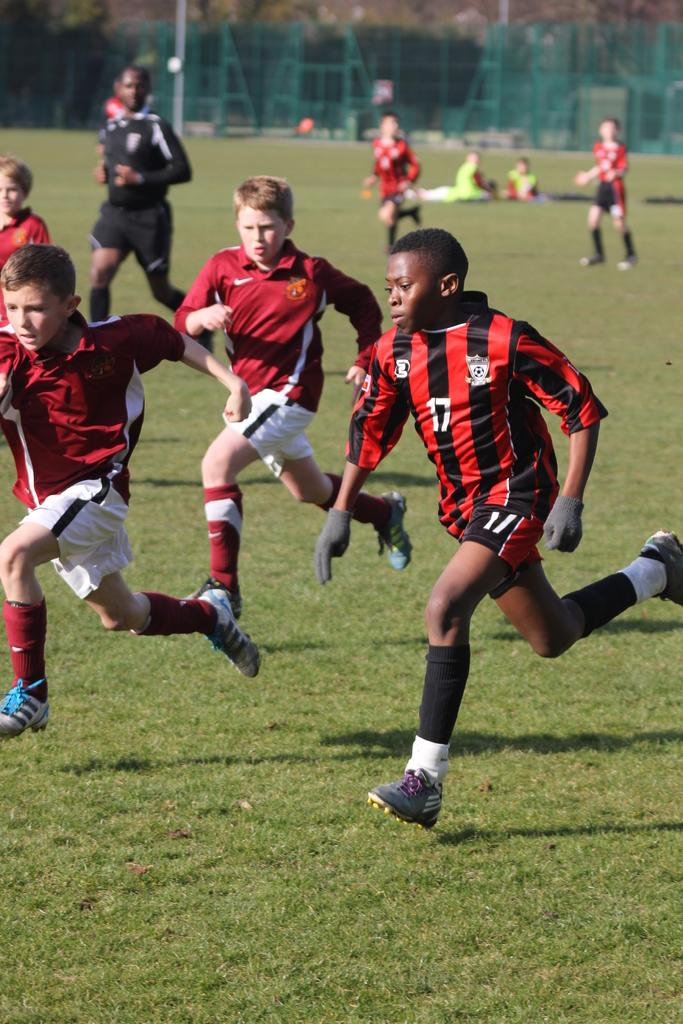<image>
Relay a brief, clear account of the picture shown. Number 17 is wearing a striped jersey while the other boys are wearing solid red. 